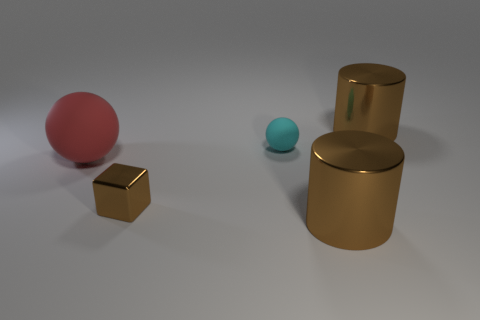Are there any other cyan things of the same shape as the cyan thing?
Your response must be concise. No. Is the sphere in front of the small rubber object made of the same material as the tiny cube on the left side of the tiny cyan matte thing?
Ensure brevity in your answer.  No. There is a red rubber ball to the left of the large brown thing to the left of the large object behind the tiny ball; what size is it?
Keep it short and to the point. Large. There is a brown thing that is the same size as the cyan object; what material is it?
Your answer should be very brief. Metal. Is there a cyan rubber object that has the same size as the cyan sphere?
Keep it short and to the point. No. Is the shape of the large red thing the same as the tiny brown object?
Provide a succinct answer. No. There is a cyan rubber object behind the object that is on the left side of the brown metal cube; is there a cylinder in front of it?
Your answer should be compact. Yes. How many other objects are the same color as the tiny ball?
Your answer should be compact. 0. Does the metal object behind the small brown shiny object have the same size as the brown cylinder in front of the metal block?
Give a very brief answer. Yes. Are there an equal number of brown shiny cylinders behind the small brown metallic thing and large brown things that are left of the cyan rubber ball?
Provide a succinct answer. No. 